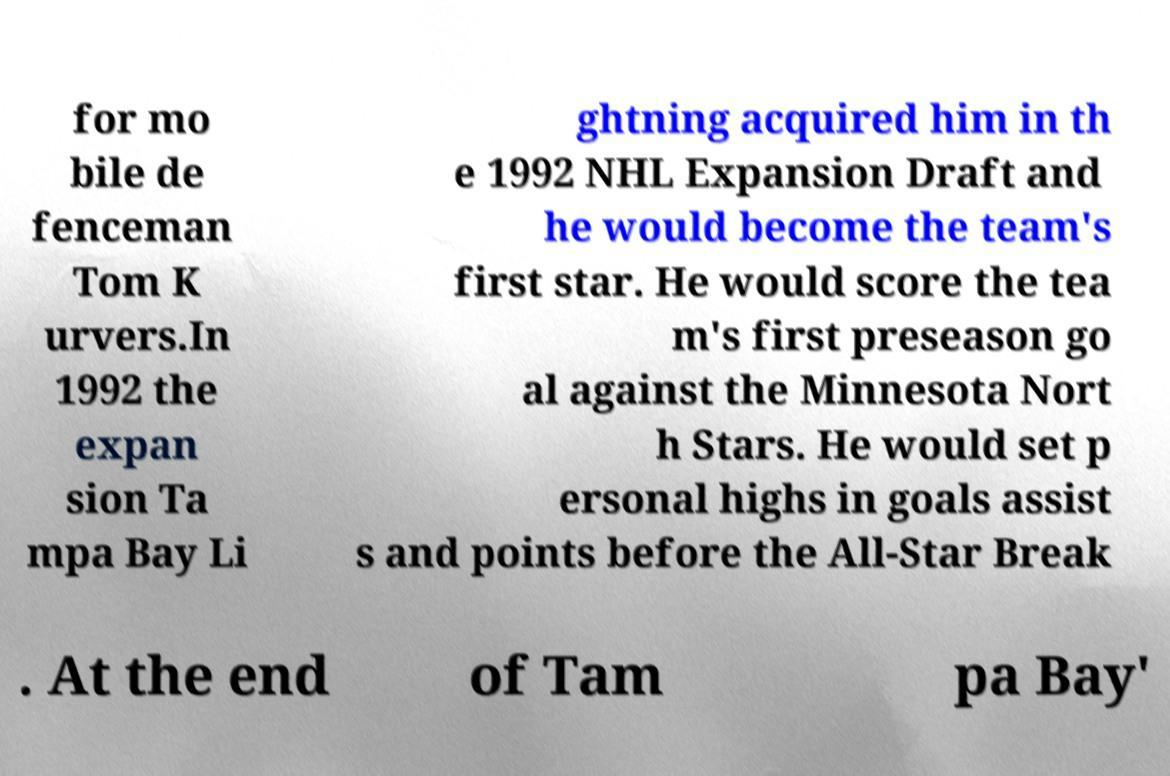I need the written content from this picture converted into text. Can you do that? for mo bile de fenceman Tom K urvers.In 1992 the expan sion Ta mpa Bay Li ghtning acquired him in th e 1992 NHL Expansion Draft and he would become the team's first star. He would score the tea m's first preseason go al against the Minnesota Nort h Stars. He would set p ersonal highs in goals assist s and points before the All-Star Break . At the end of Tam pa Bay' 